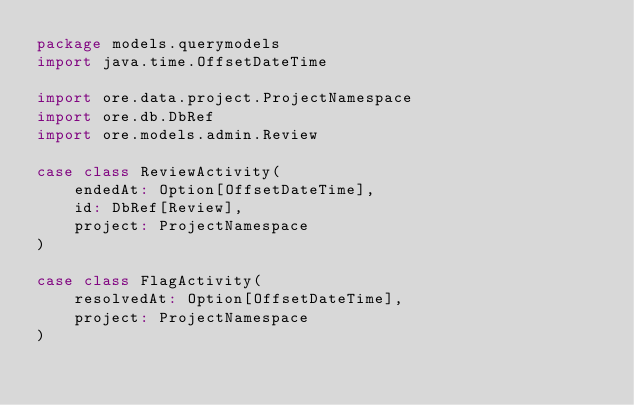Convert code to text. <code><loc_0><loc_0><loc_500><loc_500><_Scala_>package models.querymodels
import java.time.OffsetDateTime

import ore.data.project.ProjectNamespace
import ore.db.DbRef
import ore.models.admin.Review

case class ReviewActivity(
    endedAt: Option[OffsetDateTime],
    id: DbRef[Review],
    project: ProjectNamespace
)

case class FlagActivity(
    resolvedAt: Option[OffsetDateTime],
    project: ProjectNamespace
)
</code> 